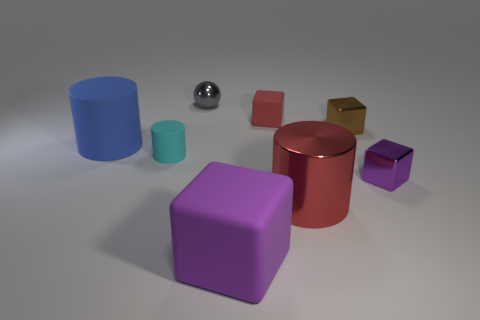Add 1 blue cylinders. How many objects exist? 9 Subtract all rubber cylinders. How many cylinders are left? 1 Subtract all red cylinders. How many purple cubes are left? 2 Subtract all blue cylinders. How many cylinders are left? 2 Subtract 1 cylinders. How many cylinders are left? 2 Subtract all balls. How many objects are left? 7 Subtract all red cubes. Subtract all yellow balls. How many cubes are left? 3 Subtract all red rubber cylinders. Subtract all shiny cylinders. How many objects are left? 7 Add 8 gray metallic objects. How many gray metallic objects are left? 9 Add 3 big red spheres. How many big red spheres exist? 3 